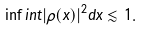<formula> <loc_0><loc_0><loc_500><loc_500>\inf i n t | \rho ( x ) | ^ { 2 } d x \lesssim 1 .</formula> 